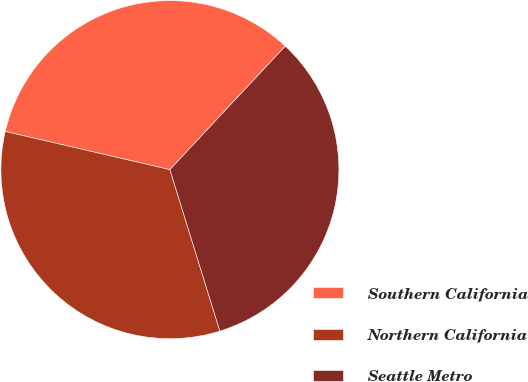Convert chart to OTSL. <chart><loc_0><loc_0><loc_500><loc_500><pie_chart><fcel>Southern California<fcel>Northern California<fcel>Seattle Metro<nl><fcel>33.33%<fcel>33.4%<fcel>33.26%<nl></chart> 